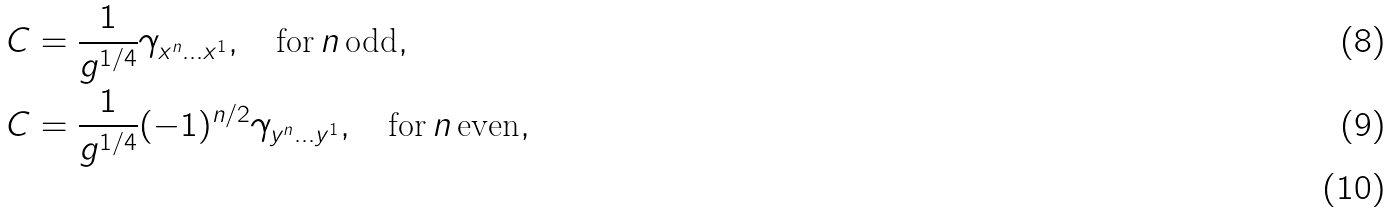<formula> <loc_0><loc_0><loc_500><loc_500>& C = \frac { 1 } { g ^ { 1 / 4 } } \gamma _ { x ^ { n } \dots x ^ { 1 } } , \quad \text {for} \, n \, { \text {odd} } , \\ & C = \frac { 1 } { g ^ { 1 / 4 } } ( - 1 ) ^ { n / 2 } \gamma _ { y ^ { n } \dots y ^ { 1 } } , \quad \text {for} \, n \, { \text {even} } , \\</formula> 